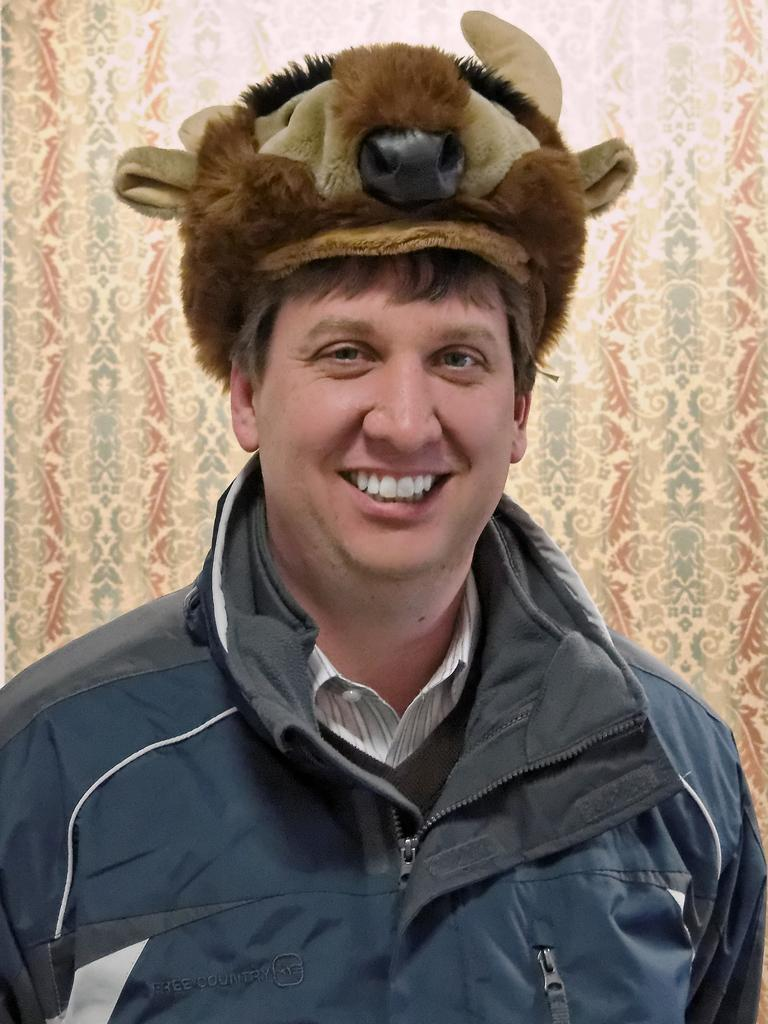What is the man in the image wearing on his upper body? The man is wearing a white shirt and a blue jacket in the image. What is the man's facial expression in the image? The man is smiling in the image. What type of headwear is the man wearing in the image? The man is wearing an animal cap in the image. What can be seen in the background of the image? There is a sheet or curtain in the background, which has cream, red, and grey colors. What note is the man holding in his hand in the image? There is no note visible in the man's hand in the image. What type of leaf is falling from the tree in the image? There is no tree or leaf present in the image. 